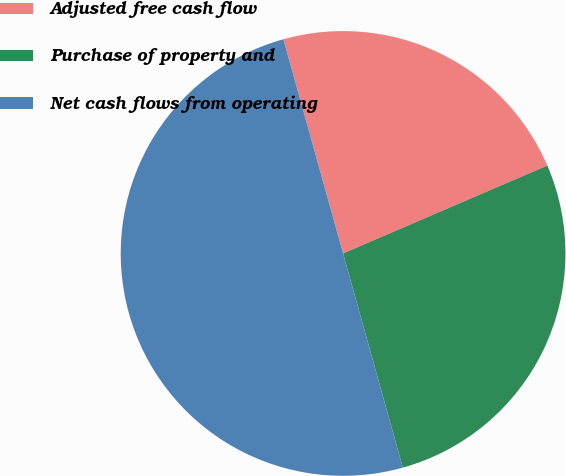<chart> <loc_0><loc_0><loc_500><loc_500><pie_chart><fcel>Adjusted free cash flow<fcel>Purchase of property and<fcel>Net cash flows from operating<nl><fcel>22.86%<fcel>27.14%<fcel>50.0%<nl></chart> 